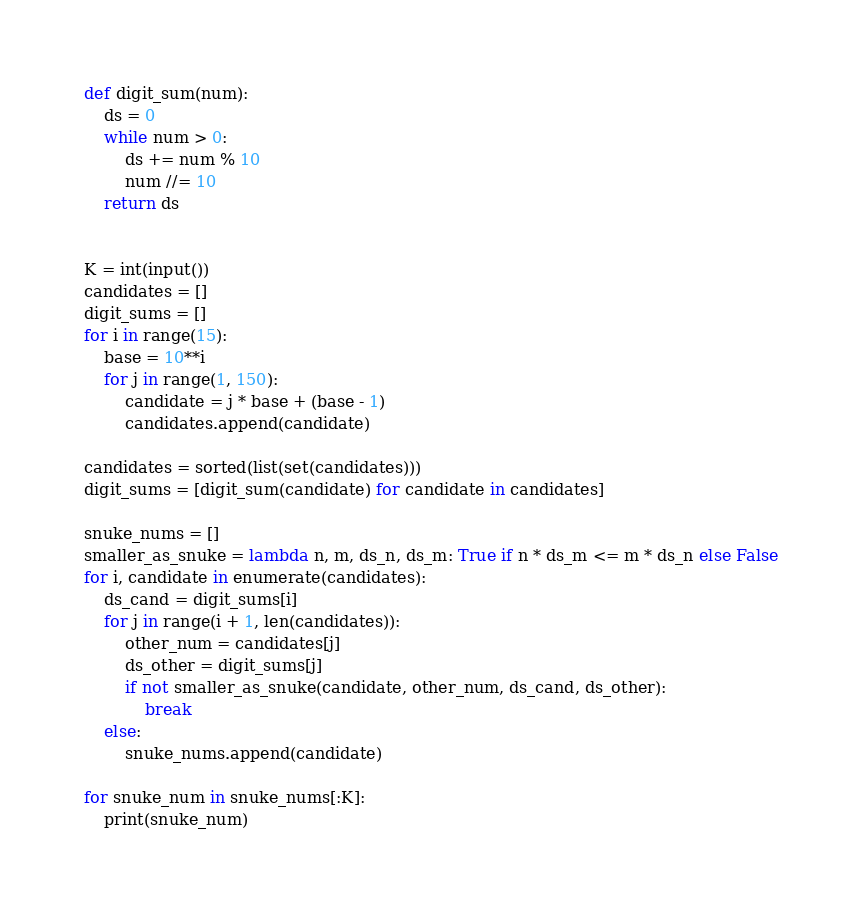Convert code to text. <code><loc_0><loc_0><loc_500><loc_500><_Python_>def digit_sum(num):
    ds = 0
    while num > 0:
        ds += num % 10
        num //= 10
    return ds


K = int(input())
candidates = []
digit_sums = []
for i in range(15):
    base = 10**i
    for j in range(1, 150):
        candidate = j * base + (base - 1)
        candidates.append(candidate)

candidates = sorted(list(set(candidates)))
digit_sums = [digit_sum(candidate) for candidate in candidates]

snuke_nums = []
smaller_as_snuke = lambda n, m, ds_n, ds_m: True if n * ds_m <= m * ds_n else False
for i, candidate in enumerate(candidates):
    ds_cand = digit_sums[i]
    for j in range(i + 1, len(candidates)):
        other_num = candidates[j]
        ds_other = digit_sums[j]
        if not smaller_as_snuke(candidate, other_num, ds_cand, ds_other):
            break
    else:
        snuke_nums.append(candidate)

for snuke_num in snuke_nums[:K]:
    print(snuke_num)
</code> 